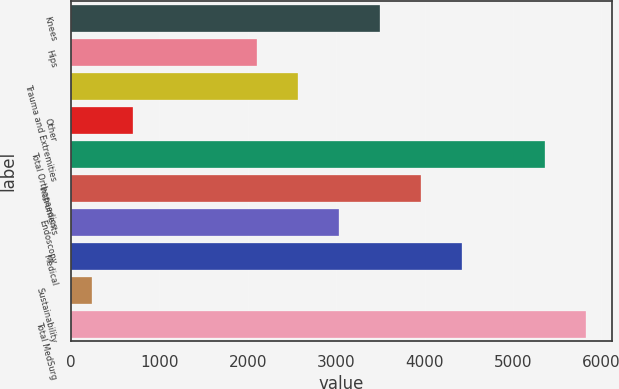Convert chart. <chart><loc_0><loc_0><loc_500><loc_500><bar_chart><fcel>Knees<fcel>Hips<fcel>Trauma and Extremities<fcel>Other<fcel>Total Orthopaedics<fcel>Instruments<fcel>Endoscopy<fcel>Medical<fcel>Sustainability<fcel>Total MedSurg<nl><fcel>3497.2<fcel>2100.4<fcel>2566<fcel>703.6<fcel>5359.6<fcel>3962.8<fcel>3031.6<fcel>4428.4<fcel>238<fcel>5825.2<nl></chart> 